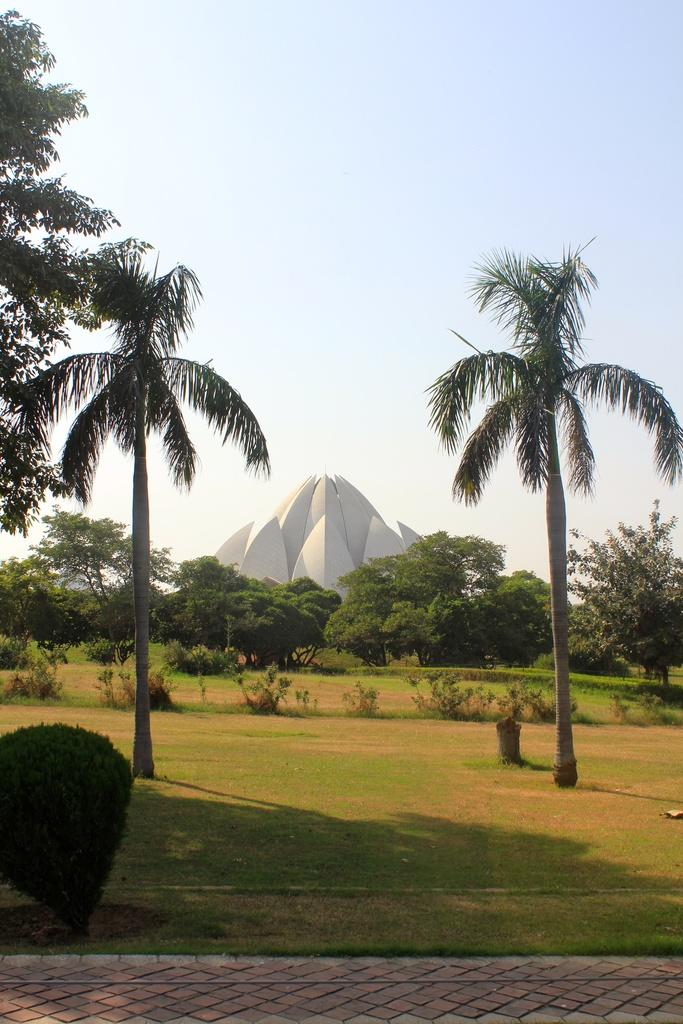What is the main structure in the image? There is a monument in the image. What type of vegetation surrounds the monument? There are trees around the monument. What type of ground cover is present in the image? There is grass in the image. What other plants can be seen in the image? There are shrubs in the image. Is there a pathway visible in the image? Yes, there is a pathway in the image. What can be seen in the sky in the image? The sky is visible in the image, and it appears cloudy. What type of bedroom furniture can be seen in the image? There is no bedroom furniture present in the image; it features a monument surrounded by vegetation and a pathway. 